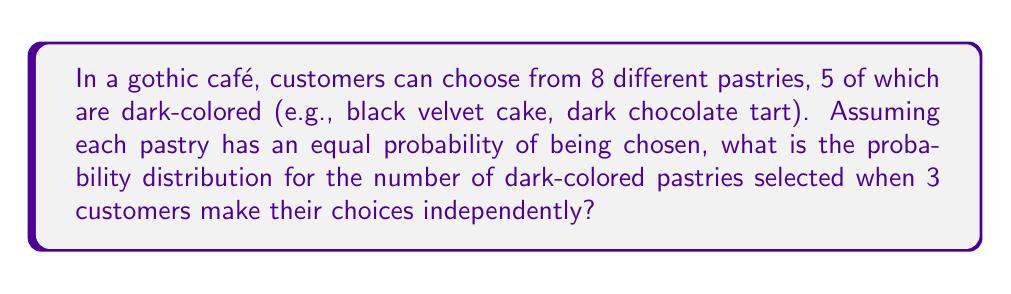Provide a solution to this math problem. Let's approach this step-by-step using the binomial distribution:

1) Each customer's choice can be considered a Bernoulli trial:
   - Success: choosing a dark-colored pastry
   - Failure: choosing a non-dark-colored pastry

2) Probability of success (p):
   $$p = \frac{\text{number of dark-colored pastries}}{\text{total number of pastries}} = \frac{5}{8}$$

3) Probability of failure (q):
   $$q = 1 - p = 1 - \frac{5}{8} = \frac{3}{8}$$

4) Number of trials (n): 3 customers

5) The probability of exactly k successes in n trials is given by the binomial probability mass function:

   $$P(X = k) = \binom{n}{k} p^k q^{n-k}$$

6) Let's calculate for k = 0, 1, 2, and 3:

   For k = 0: $$P(X = 0) = \binom{3}{0} (\frac{5}{8})^0 (\frac{3}{8})^3 = 1 \cdot 1 \cdot \frac{27}{512} = \frac{27}{512}$$

   For k = 1: $$P(X = 1) = \binom{3}{1} (\frac{5}{8})^1 (\frac{3}{8})^2 = 3 \cdot \frac{5}{8} \cdot \frac{9}{64} = \frac{135}{512}$$

   For k = 2: $$P(X = 2) = \binom{3}{2} (\frac{5}{8})^2 (\frac{3}{8})^1 = 3 \cdot \frac{25}{64} \cdot \frac{3}{8} = \frac{225}{512}$$

   For k = 3: $$P(X = 3) = \binom{3}{3} (\frac{5}{8})^3 (\frac{3}{8})^0 = 1 \cdot \frac{125}{512} \cdot 1 = \frac{125}{512}$$

7) The probability distribution is the set of these probabilities for each possible outcome.
Answer: $P(X = k) = \{\frac{27}{512}, \frac{135}{512}, \frac{225}{512}, \frac{125}{512}\}$ for $k = 0, 1, 2, 3$ respectively 